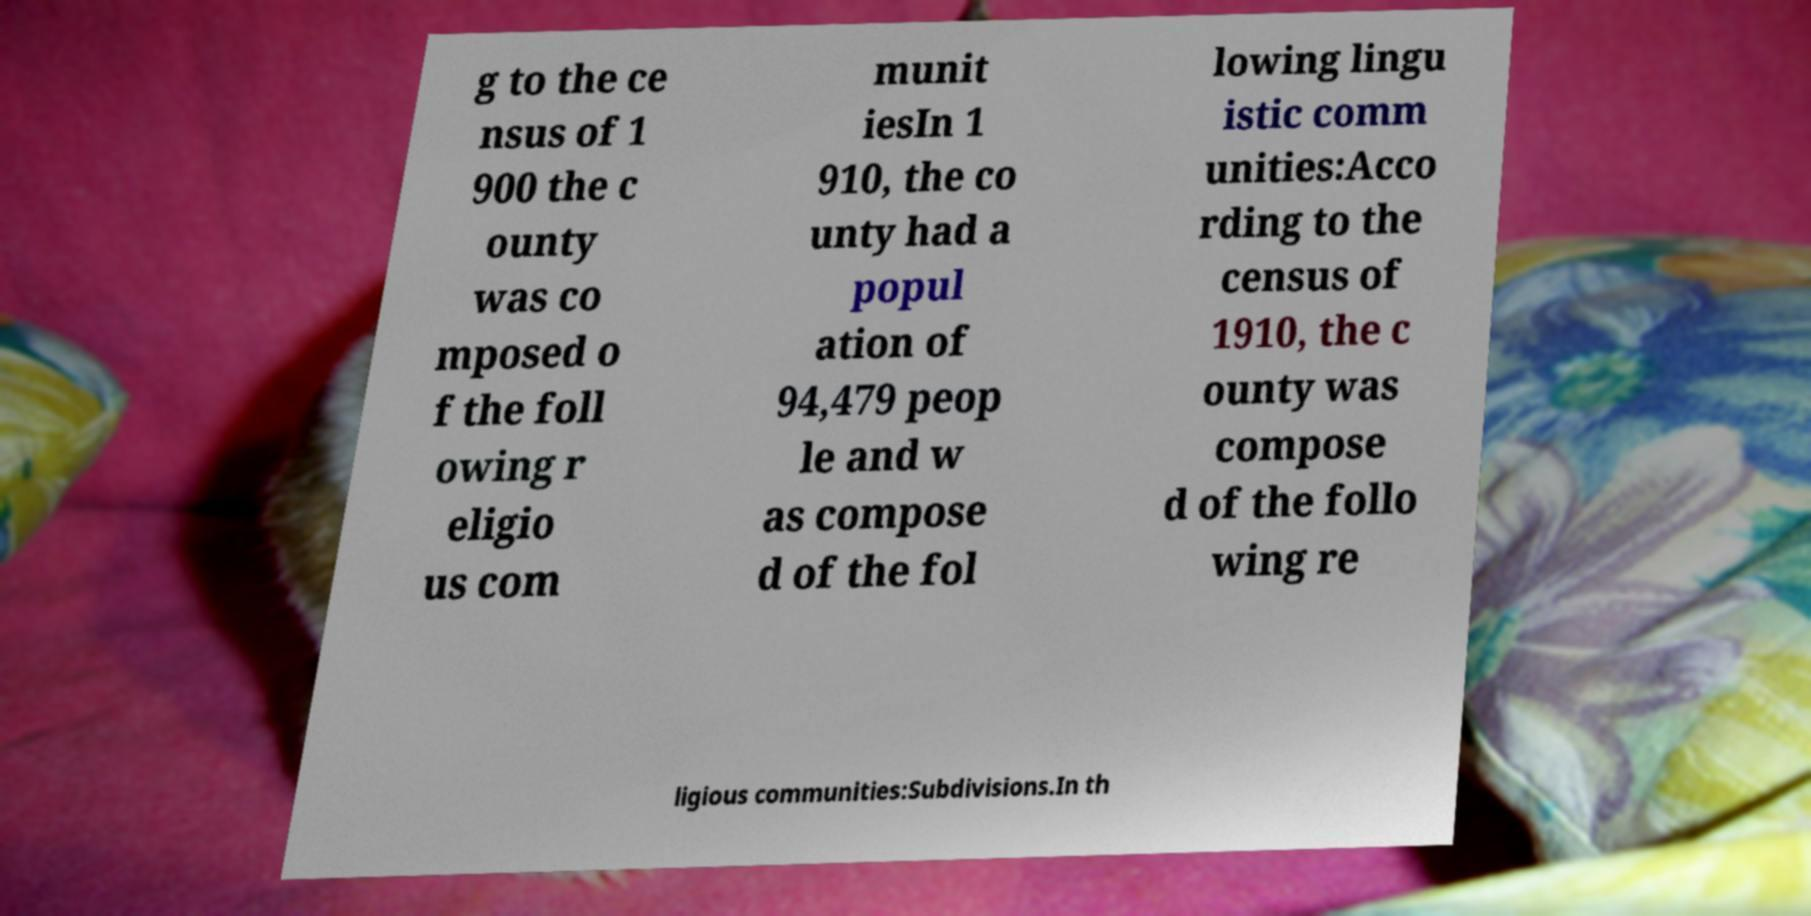What messages or text are displayed in this image? I need them in a readable, typed format. g to the ce nsus of 1 900 the c ounty was co mposed o f the foll owing r eligio us com munit iesIn 1 910, the co unty had a popul ation of 94,479 peop le and w as compose d of the fol lowing lingu istic comm unities:Acco rding to the census of 1910, the c ounty was compose d of the follo wing re ligious communities:Subdivisions.In th 